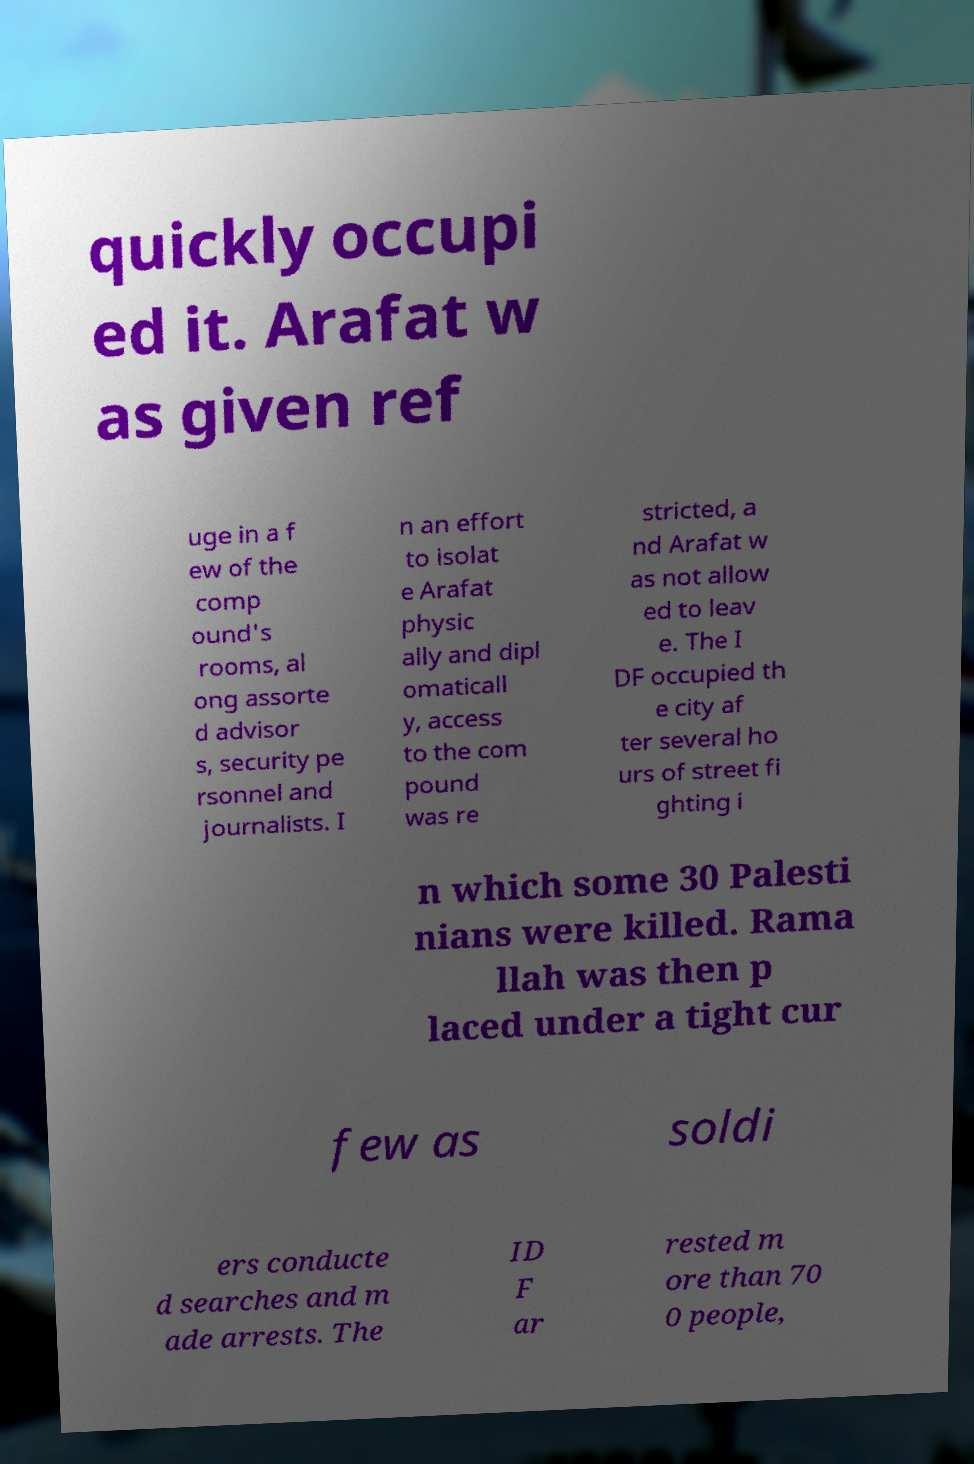Can you read and provide the text displayed in the image?This photo seems to have some interesting text. Can you extract and type it out for me? quickly occupi ed it. Arafat w as given ref uge in a f ew of the comp ound's rooms, al ong assorte d advisor s, security pe rsonnel and journalists. I n an effort to isolat e Arafat physic ally and dipl omaticall y, access to the com pound was re stricted, a nd Arafat w as not allow ed to leav e. The I DF occupied th e city af ter several ho urs of street fi ghting i n which some 30 Palesti nians were killed. Rama llah was then p laced under a tight cur few as soldi ers conducte d searches and m ade arrests. The ID F ar rested m ore than 70 0 people, 